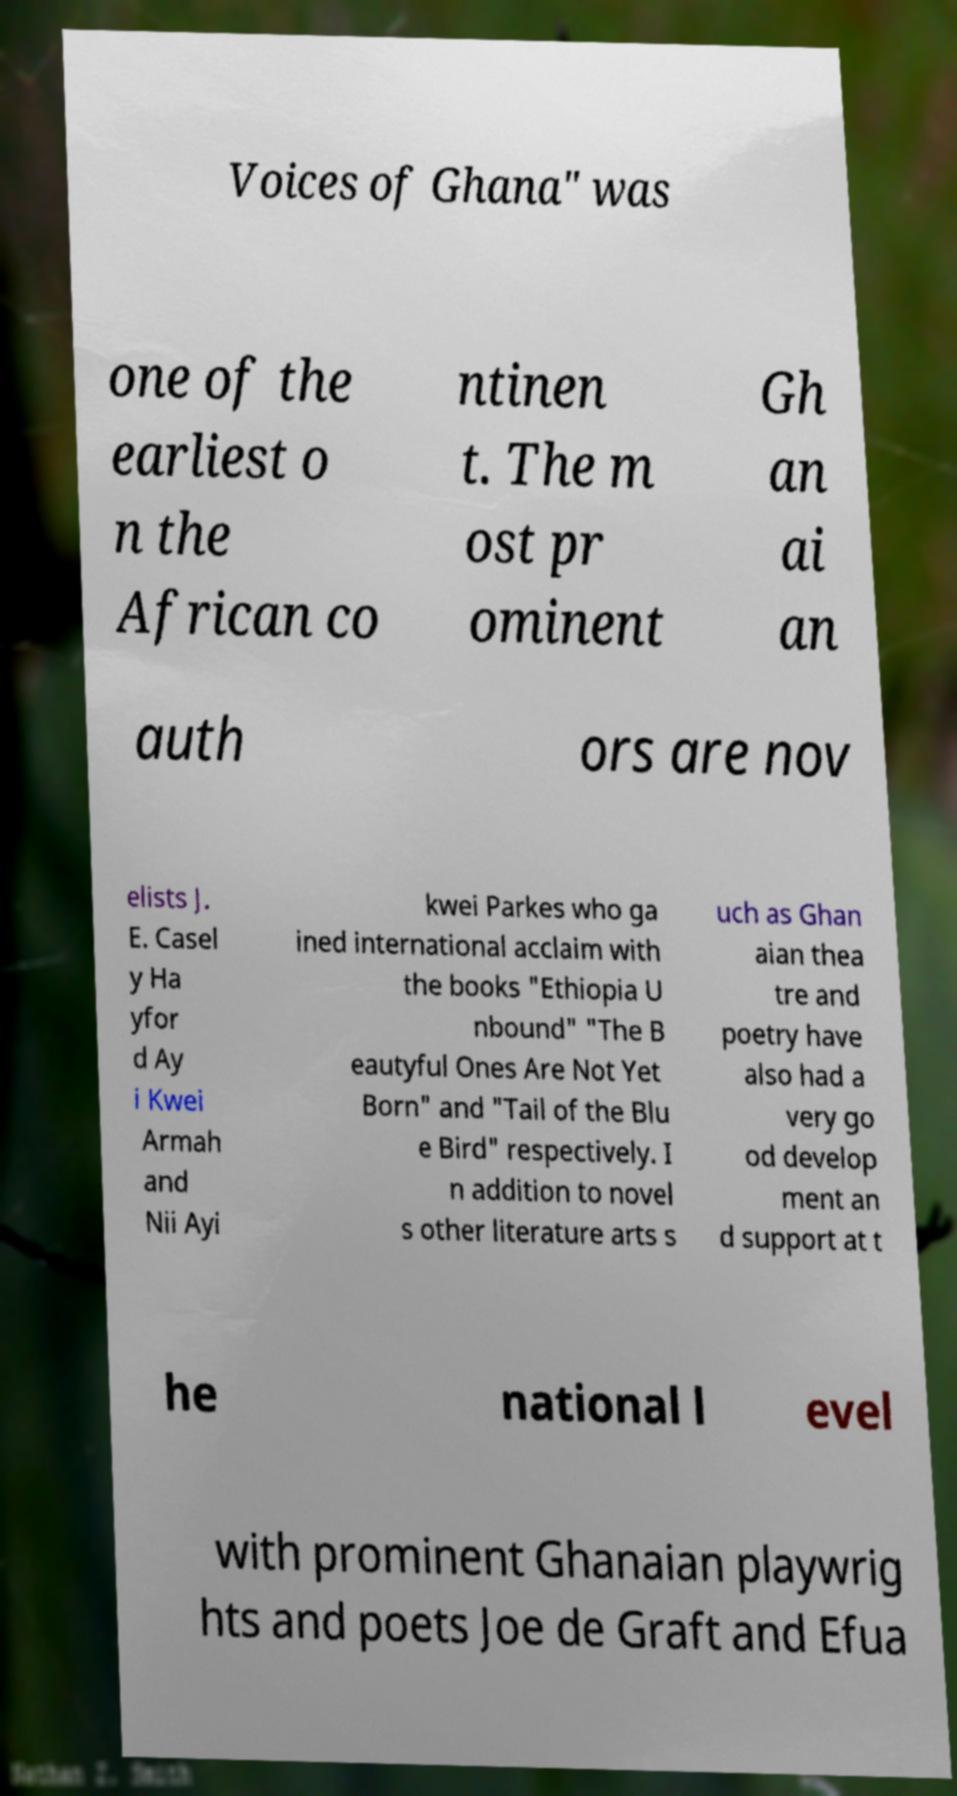I need the written content from this picture converted into text. Can you do that? Voices of Ghana" was one of the earliest o n the African co ntinen t. The m ost pr ominent Gh an ai an auth ors are nov elists J. E. Casel y Ha yfor d Ay i Kwei Armah and Nii Ayi kwei Parkes who ga ined international acclaim with the books "Ethiopia U nbound" "The B eautyful Ones Are Not Yet Born" and "Tail of the Blu e Bird" respectively. I n addition to novel s other literature arts s uch as Ghan aian thea tre and poetry have also had a very go od develop ment an d support at t he national l evel with prominent Ghanaian playwrig hts and poets Joe de Graft and Efua 